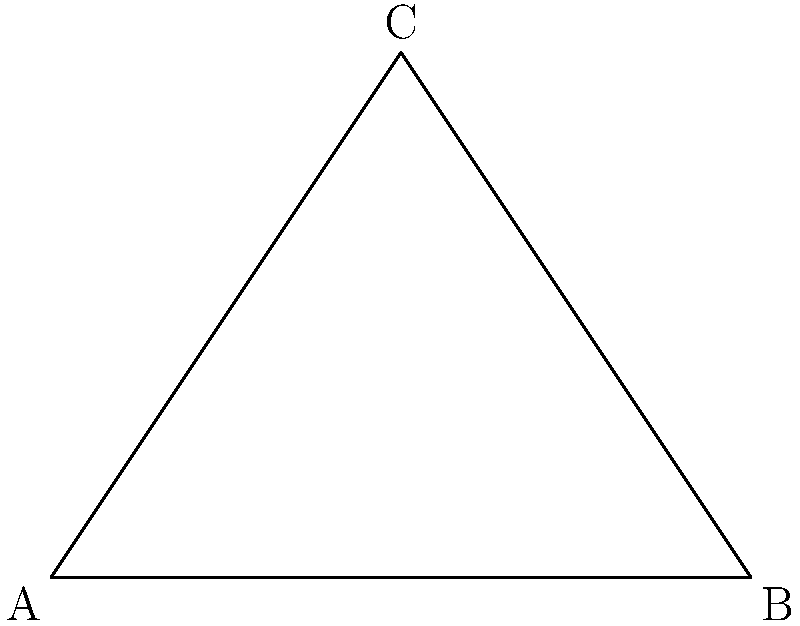In your latest mural project depicting Jesse Owens' iconic long jump at the 1936 Berlin Olympics, you've incorporated a triangular composition to represent the trajectory of his jump. If the angle at the apex of the triangle is 90°, and one of the base angles is 30°, what is the measure of the other base angle? Let's approach this step-by-step:

1. In any triangle, the sum of all interior angles is always 180°.

2. We're given that:
   - The angle at the apex (C) is 90°
   - One of the base angles (let's say at A) is 30°

3. Let's call the unknown base angle (at B) x°.

4. We can set up an equation based on the fact that the sum of angles in a triangle is 180°:
   
   $90° + 30° + x° = 180°$

5. Simplify:
   $120° + x° = 180°$

6. Subtract 120° from both sides:
   $x° = 180° - 120° = 60°$

Therefore, the measure of the other base angle is 60°.

This triangular composition not only represents the trajectory of Jesse Owens' jump but also incorporates the golden ratio (approximately 1:1.618), as the 30-60-90 triangle is considered a "golden triangle."
Answer: 60° 